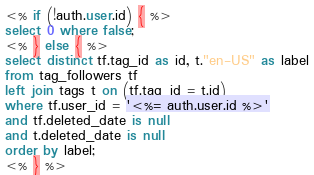<code> <loc_0><loc_0><loc_500><loc_500><_SQL_><% if (!auth.user.id) { %>
select 0 where false;
<% } else { %>
select distinct tf.tag_id as id, t."en-US" as label
from tag_followers tf
left join tags t on (tf.tag_id = t.id)
where tf.user_id = '<%= auth.user.id %>'
and tf.deleted_date is null
and t.deleted_date is null
order by label;
<% } %>
</code> 